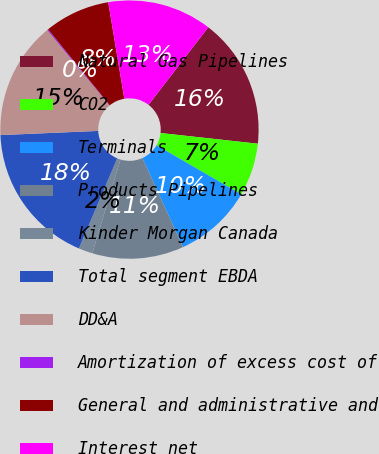Convert chart. <chart><loc_0><loc_0><loc_500><loc_500><pie_chart><fcel>Natural Gas Pipelines<fcel>CO2<fcel>Terminals<fcel>Products Pipelines<fcel>Kinder Morgan Canada<fcel>Total segment EBDA<fcel>DD&A<fcel>Amortization of excess cost of<fcel>General and administrative and<fcel>Interest net<nl><fcel>16.3%<fcel>6.61%<fcel>9.84%<fcel>11.45%<fcel>1.76%<fcel>17.92%<fcel>14.69%<fcel>0.14%<fcel>8.22%<fcel>13.07%<nl></chart> 